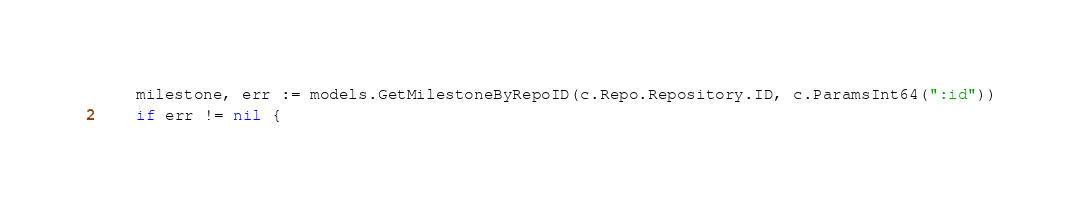<code> <loc_0><loc_0><loc_500><loc_500><_Go_>	milestone, err := models.GetMilestoneByRepoID(c.Repo.Repository.ID, c.ParamsInt64(":id"))
	if err != nil {</code> 